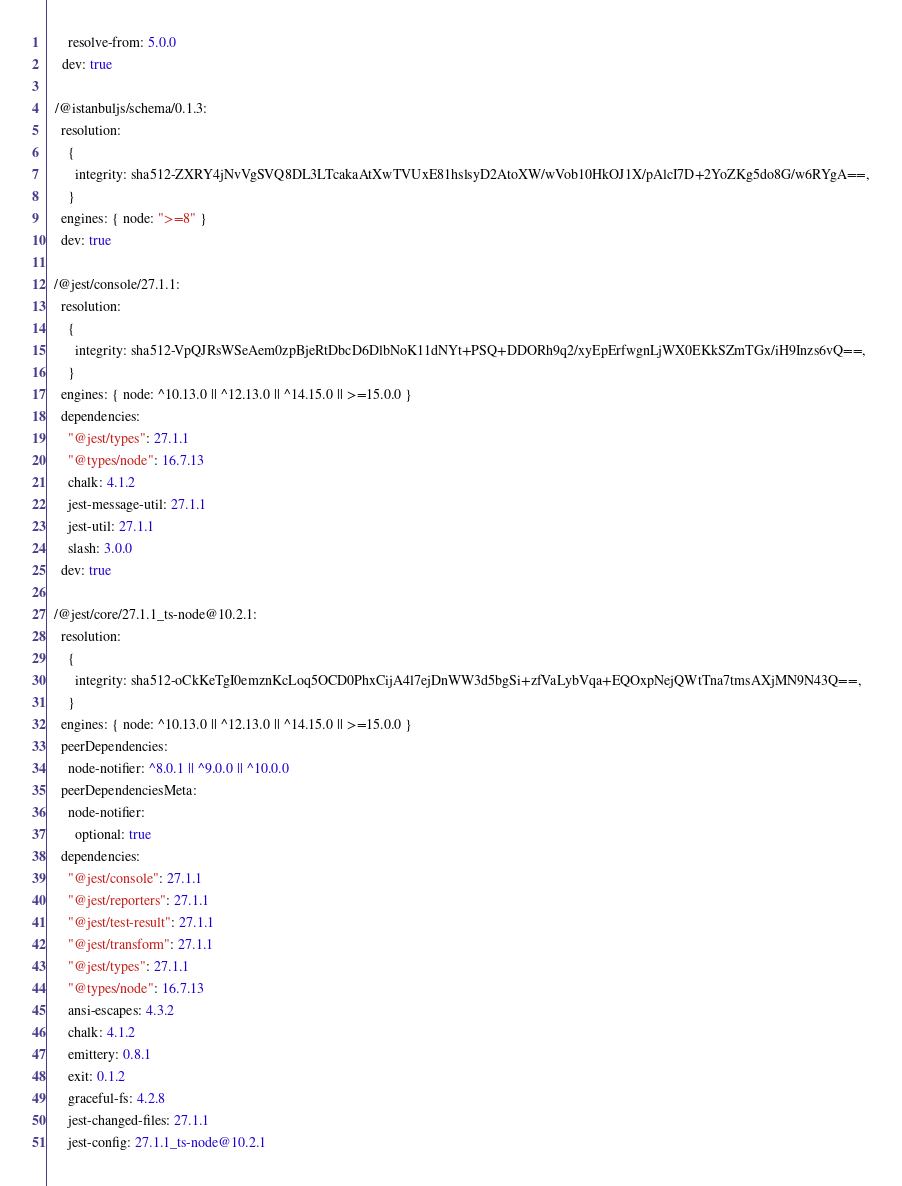Convert code to text. <code><loc_0><loc_0><loc_500><loc_500><_YAML_>      resolve-from: 5.0.0
    dev: true

  /@istanbuljs/schema/0.1.3:
    resolution:
      {
        integrity: sha512-ZXRY4jNvVgSVQ8DL3LTcakaAtXwTVUxE81hslsyD2AtoXW/wVob10HkOJ1X/pAlcI7D+2YoZKg5do8G/w6RYgA==,
      }
    engines: { node: ">=8" }
    dev: true

  /@jest/console/27.1.1:
    resolution:
      {
        integrity: sha512-VpQJRsWSeAem0zpBjeRtDbcD6DlbNoK11dNYt+PSQ+DDORh9q2/xyEpErfwgnLjWX0EKkSZmTGx/iH9Inzs6vQ==,
      }
    engines: { node: ^10.13.0 || ^12.13.0 || ^14.15.0 || >=15.0.0 }
    dependencies:
      "@jest/types": 27.1.1
      "@types/node": 16.7.13
      chalk: 4.1.2
      jest-message-util: 27.1.1
      jest-util: 27.1.1
      slash: 3.0.0
    dev: true

  /@jest/core/27.1.1_ts-node@10.2.1:
    resolution:
      {
        integrity: sha512-oCkKeTgI0emznKcLoq5OCD0PhxCijA4l7ejDnWW3d5bgSi+zfVaLybVqa+EQOxpNejQWtTna7tmsAXjMN9N43Q==,
      }
    engines: { node: ^10.13.0 || ^12.13.0 || ^14.15.0 || >=15.0.0 }
    peerDependencies:
      node-notifier: ^8.0.1 || ^9.0.0 || ^10.0.0
    peerDependenciesMeta:
      node-notifier:
        optional: true
    dependencies:
      "@jest/console": 27.1.1
      "@jest/reporters": 27.1.1
      "@jest/test-result": 27.1.1
      "@jest/transform": 27.1.1
      "@jest/types": 27.1.1
      "@types/node": 16.7.13
      ansi-escapes: 4.3.2
      chalk: 4.1.2
      emittery: 0.8.1
      exit: 0.1.2
      graceful-fs: 4.2.8
      jest-changed-files: 27.1.1
      jest-config: 27.1.1_ts-node@10.2.1</code> 